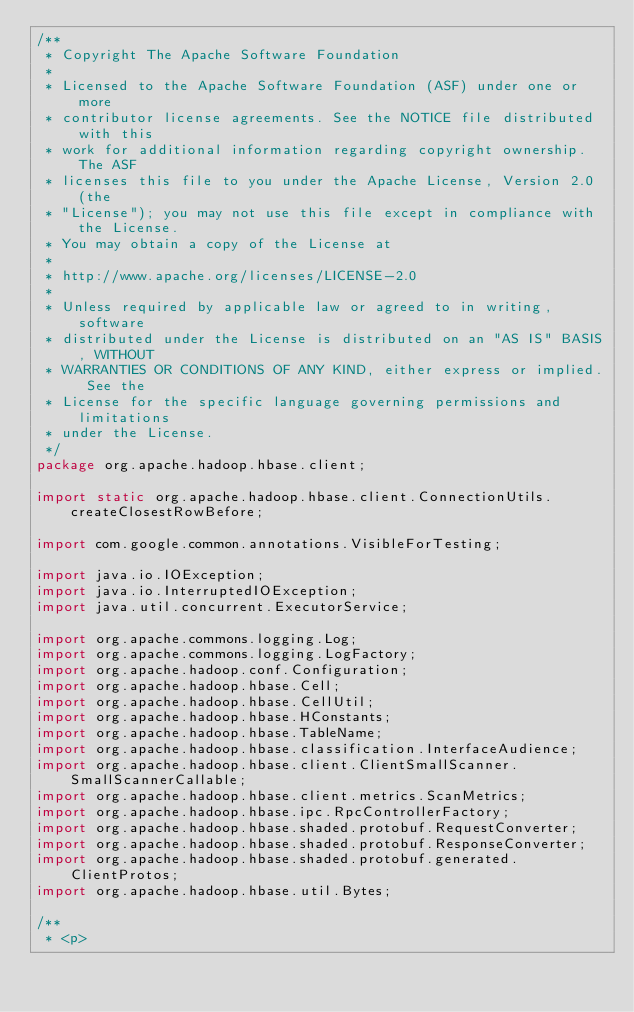<code> <loc_0><loc_0><loc_500><loc_500><_Java_>/**
 * Copyright The Apache Software Foundation
 *
 * Licensed to the Apache Software Foundation (ASF) under one or more
 * contributor license agreements. See the NOTICE file distributed with this
 * work for additional information regarding copyright ownership. The ASF
 * licenses this file to you under the Apache License, Version 2.0 (the
 * "License"); you may not use this file except in compliance with the License.
 * You may obtain a copy of the License at
 *
 * http://www.apache.org/licenses/LICENSE-2.0
 *
 * Unless required by applicable law or agreed to in writing, software
 * distributed under the License is distributed on an "AS IS" BASIS, WITHOUT
 * WARRANTIES OR CONDITIONS OF ANY KIND, either express or implied. See the
 * License for the specific language governing permissions and limitations
 * under the License.
 */
package org.apache.hadoop.hbase.client;

import static org.apache.hadoop.hbase.client.ConnectionUtils.createClosestRowBefore;

import com.google.common.annotations.VisibleForTesting;

import java.io.IOException;
import java.io.InterruptedIOException;
import java.util.concurrent.ExecutorService;

import org.apache.commons.logging.Log;
import org.apache.commons.logging.LogFactory;
import org.apache.hadoop.conf.Configuration;
import org.apache.hadoop.hbase.Cell;
import org.apache.hadoop.hbase.CellUtil;
import org.apache.hadoop.hbase.HConstants;
import org.apache.hadoop.hbase.TableName;
import org.apache.hadoop.hbase.classification.InterfaceAudience;
import org.apache.hadoop.hbase.client.ClientSmallScanner.SmallScannerCallable;
import org.apache.hadoop.hbase.client.metrics.ScanMetrics;
import org.apache.hadoop.hbase.ipc.RpcControllerFactory;
import org.apache.hadoop.hbase.shaded.protobuf.RequestConverter;
import org.apache.hadoop.hbase.shaded.protobuf.ResponseConverter;
import org.apache.hadoop.hbase.shaded.protobuf.generated.ClientProtos;
import org.apache.hadoop.hbase.util.Bytes;

/**
 * <p></code> 